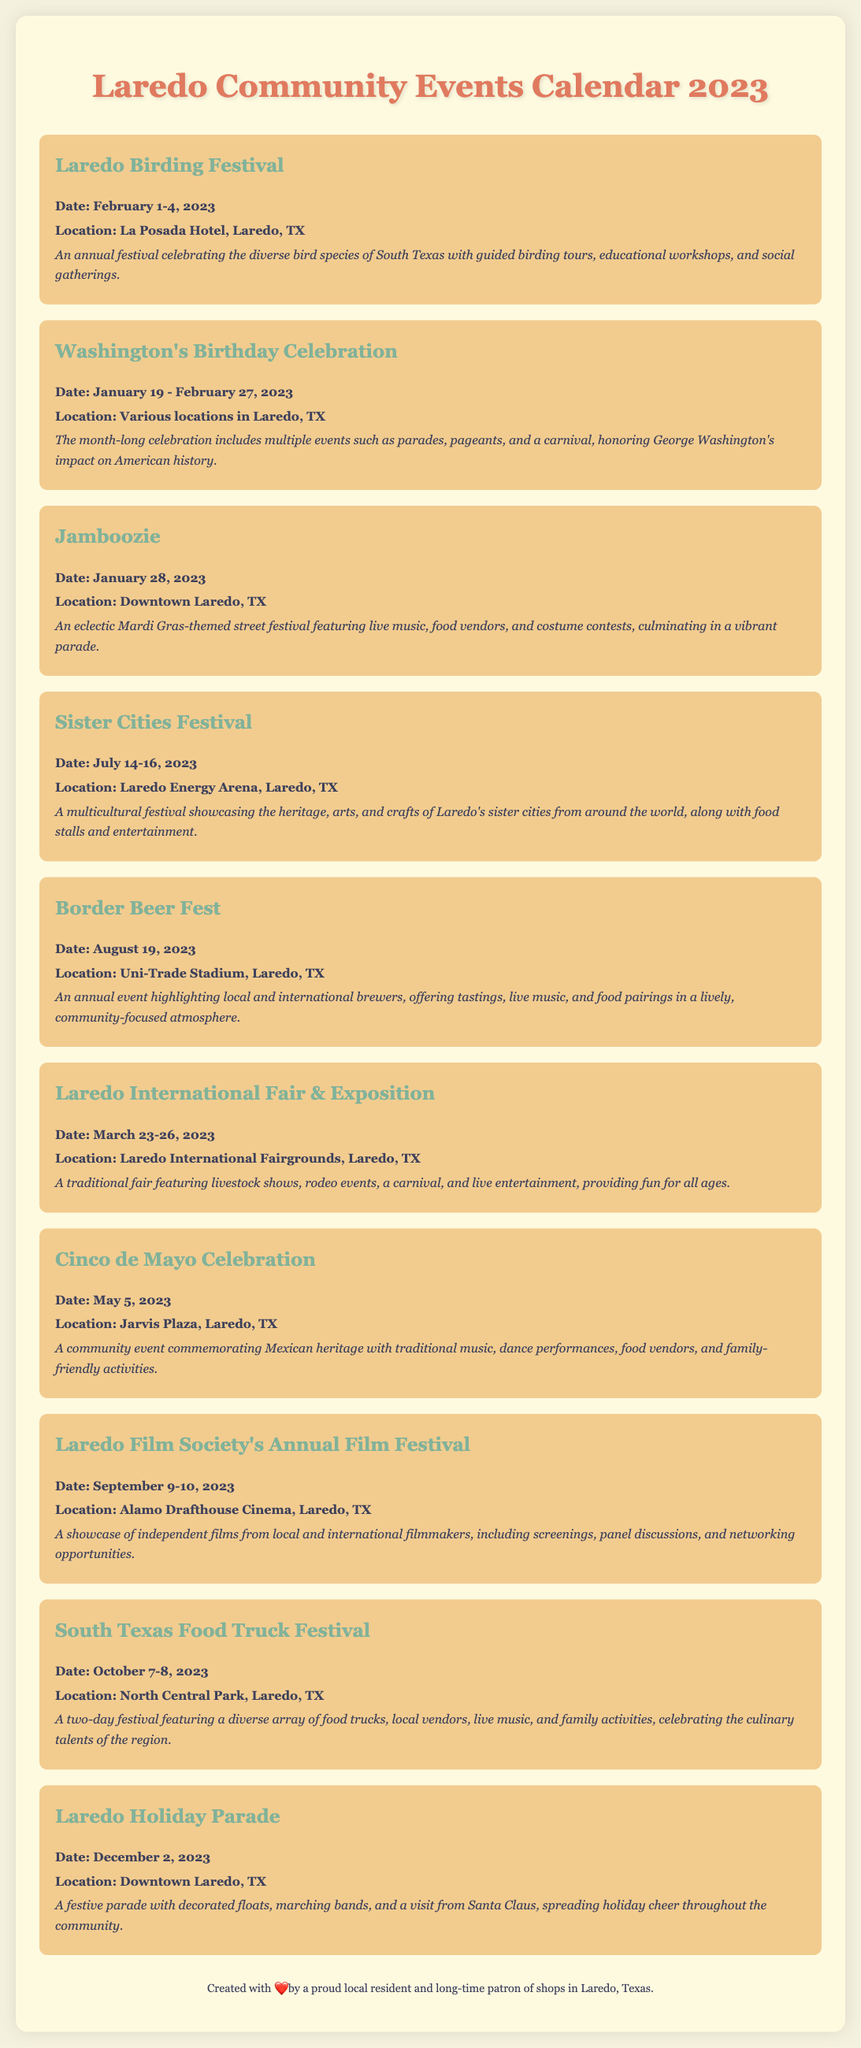What is the date of the Laredo Birding Festival? The date for the Laredo Birding Festival is specifically mentioned in the document as February 1-4, 2023.
Answer: February 1-4, 2023 Where is the Washington's Birthday Celebration held? The document states that the Washington's Birthday Celebration takes place at various locations in Laredo, TX.
Answer: Various locations in Laredo, TX How many days does the Sister Cities Festival last? The duration of the Sister Cities Festival mentioned in the document is three days, from July 14-16, 2023.
Answer: Three days What type of event is the Border Beer Fest? The document classifies the Border Beer Fest as an annual event highlighting local and international brewers with tastings and live music.
Answer: Beer festival Which event occurs on May 5, 2023? The document explicitly states that the Cinco de Mayo Celebration occurs on this date.
Answer: Cinco de Mayo Celebration What is the location for the Laredo International Fair & Exposition? The location for the Laredo International Fair & Exposition is specified in the document as Laredo International Fairgrounds, Laredo, TX.
Answer: Laredo International Fairgrounds, Laredo, TX When is the Laredo Holiday Parade scheduled? According to the document, the Laredo Holiday Parade is scheduled for December 2, 2023.
Answer: December 2, 2023 What type of activities are featured at the South Texas Food Truck Festival? The document mentions a variety of activities at the South Texas Food Truck Festival including food trucks, local vendors, live music, and family activities.
Answer: Food trucks, live music, family activities What is unique about the Jamboozie event? The Jamboozie event is characterized as a Mardi Gras-themed street festival, which is highlighted in the document.
Answer: Mardi Gras-themed street festival 